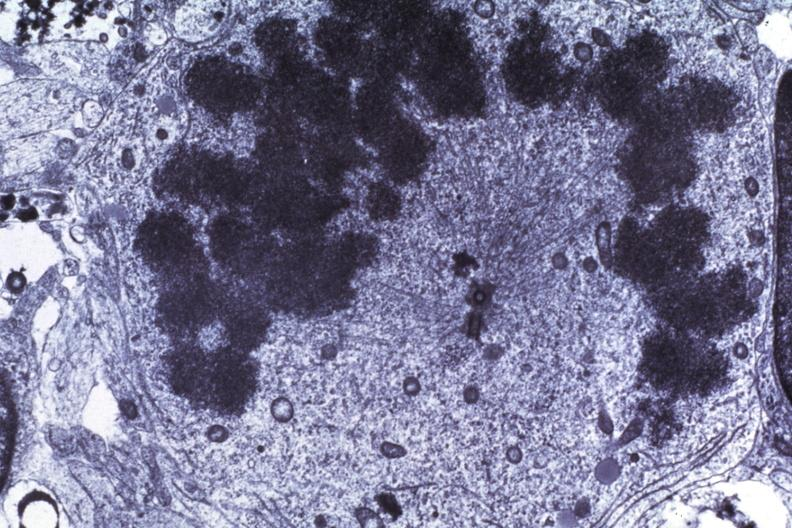s this present?
Answer the question using a single word or phrase. No 